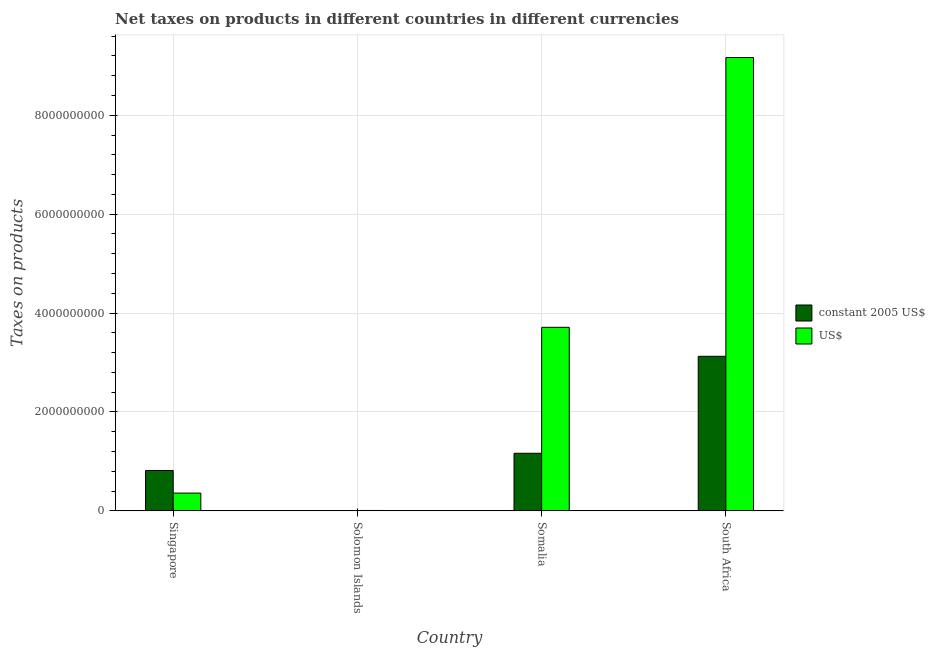How many different coloured bars are there?
Keep it short and to the point. 2. Are the number of bars on each tick of the X-axis equal?
Provide a succinct answer. Yes. How many bars are there on the 1st tick from the right?
Provide a short and direct response. 2. What is the label of the 1st group of bars from the left?
Your answer should be very brief. Singapore. What is the net taxes in constant 2005 us$ in Somalia?
Make the answer very short. 1.16e+09. Across all countries, what is the maximum net taxes in constant 2005 us$?
Provide a succinct answer. 3.12e+09. Across all countries, what is the minimum net taxes in constant 2005 us$?
Your answer should be compact. 6.60e+06. In which country was the net taxes in us$ maximum?
Provide a succinct answer. South Africa. In which country was the net taxes in us$ minimum?
Keep it short and to the point. Solomon Islands. What is the total net taxes in constant 2005 us$ in the graph?
Provide a succinct answer. 5.11e+09. What is the difference between the net taxes in constant 2005 us$ in Singapore and that in Somalia?
Offer a very short reply. -3.48e+08. What is the difference between the net taxes in us$ in Solomon Islands and the net taxes in constant 2005 us$ in South Africa?
Your answer should be compact. -3.12e+09. What is the average net taxes in us$ per country?
Provide a succinct answer. 3.31e+09. What is the difference between the net taxes in us$ and net taxes in constant 2005 us$ in Somalia?
Your answer should be very brief. 2.55e+09. What is the ratio of the net taxes in constant 2005 us$ in Solomon Islands to that in Somalia?
Your answer should be very brief. 0.01. What is the difference between the highest and the second highest net taxes in constant 2005 us$?
Keep it short and to the point. 1.96e+09. What is the difference between the highest and the lowest net taxes in constant 2005 us$?
Make the answer very short. 3.12e+09. What does the 1st bar from the left in Singapore represents?
Your answer should be compact. Constant 2005 us$. What does the 2nd bar from the right in South Africa represents?
Your answer should be very brief. Constant 2005 us$. How many bars are there?
Give a very brief answer. 8. What is the difference between two consecutive major ticks on the Y-axis?
Your response must be concise. 2.00e+09. Does the graph contain any zero values?
Provide a succinct answer. No. Does the graph contain grids?
Give a very brief answer. Yes. Where does the legend appear in the graph?
Your response must be concise. Center right. How many legend labels are there?
Provide a short and direct response. 2. How are the legend labels stacked?
Provide a short and direct response. Vertical. What is the title of the graph?
Ensure brevity in your answer.  Net taxes on products in different countries in different currencies. What is the label or title of the Y-axis?
Keep it short and to the point. Taxes on products. What is the Taxes on products of constant 2005 US$ in Singapore?
Offer a very short reply. 8.16e+08. What is the Taxes on products of US$ in Singapore?
Your answer should be very brief. 3.59e+08. What is the Taxes on products of constant 2005 US$ in Solomon Islands?
Your answer should be very brief. 6.60e+06. What is the Taxes on products of US$ in Solomon Islands?
Ensure brevity in your answer.  7.62e+06. What is the Taxes on products of constant 2005 US$ in Somalia?
Give a very brief answer. 1.16e+09. What is the Taxes on products in US$ in Somalia?
Ensure brevity in your answer.  3.71e+09. What is the Taxes on products in constant 2005 US$ in South Africa?
Your response must be concise. 3.12e+09. What is the Taxes on products in US$ in South Africa?
Offer a terse response. 9.17e+09. Across all countries, what is the maximum Taxes on products of constant 2005 US$?
Offer a very short reply. 3.12e+09. Across all countries, what is the maximum Taxes on products in US$?
Your answer should be very brief. 9.17e+09. Across all countries, what is the minimum Taxes on products in constant 2005 US$?
Keep it short and to the point. 6.60e+06. Across all countries, what is the minimum Taxes on products of US$?
Offer a very short reply. 7.62e+06. What is the total Taxes on products in constant 2005 US$ in the graph?
Your answer should be very brief. 5.11e+09. What is the total Taxes on products in US$ in the graph?
Provide a short and direct response. 1.32e+1. What is the difference between the Taxes on products of constant 2005 US$ in Singapore and that in Solomon Islands?
Keep it short and to the point. 8.09e+08. What is the difference between the Taxes on products in US$ in Singapore and that in Solomon Islands?
Provide a short and direct response. 3.51e+08. What is the difference between the Taxes on products of constant 2005 US$ in Singapore and that in Somalia?
Your response must be concise. -3.48e+08. What is the difference between the Taxes on products of US$ in Singapore and that in Somalia?
Your answer should be very brief. -3.35e+09. What is the difference between the Taxes on products in constant 2005 US$ in Singapore and that in South Africa?
Give a very brief answer. -2.31e+09. What is the difference between the Taxes on products in US$ in Singapore and that in South Africa?
Make the answer very short. -8.81e+09. What is the difference between the Taxes on products in constant 2005 US$ in Solomon Islands and that in Somalia?
Your answer should be compact. -1.16e+09. What is the difference between the Taxes on products in US$ in Solomon Islands and that in Somalia?
Offer a terse response. -3.70e+09. What is the difference between the Taxes on products in constant 2005 US$ in Solomon Islands and that in South Africa?
Offer a very short reply. -3.12e+09. What is the difference between the Taxes on products of US$ in Solomon Islands and that in South Africa?
Give a very brief answer. -9.16e+09. What is the difference between the Taxes on products in constant 2005 US$ in Somalia and that in South Africa?
Your response must be concise. -1.96e+09. What is the difference between the Taxes on products in US$ in Somalia and that in South Africa?
Give a very brief answer. -5.46e+09. What is the difference between the Taxes on products in constant 2005 US$ in Singapore and the Taxes on products in US$ in Solomon Islands?
Make the answer very short. 8.08e+08. What is the difference between the Taxes on products in constant 2005 US$ in Singapore and the Taxes on products in US$ in Somalia?
Your response must be concise. -2.90e+09. What is the difference between the Taxes on products of constant 2005 US$ in Singapore and the Taxes on products of US$ in South Africa?
Make the answer very short. -8.35e+09. What is the difference between the Taxes on products of constant 2005 US$ in Solomon Islands and the Taxes on products of US$ in Somalia?
Your answer should be compact. -3.70e+09. What is the difference between the Taxes on products of constant 2005 US$ in Solomon Islands and the Taxes on products of US$ in South Africa?
Provide a succinct answer. -9.16e+09. What is the difference between the Taxes on products in constant 2005 US$ in Somalia and the Taxes on products in US$ in South Africa?
Your answer should be compact. -8.00e+09. What is the average Taxes on products in constant 2005 US$ per country?
Your response must be concise. 1.28e+09. What is the average Taxes on products of US$ per country?
Offer a very short reply. 3.31e+09. What is the difference between the Taxes on products of constant 2005 US$ and Taxes on products of US$ in Singapore?
Provide a short and direct response. 4.57e+08. What is the difference between the Taxes on products in constant 2005 US$ and Taxes on products in US$ in Solomon Islands?
Keep it short and to the point. -1.02e+06. What is the difference between the Taxes on products in constant 2005 US$ and Taxes on products in US$ in Somalia?
Offer a terse response. -2.55e+09. What is the difference between the Taxes on products of constant 2005 US$ and Taxes on products of US$ in South Africa?
Offer a terse response. -6.04e+09. What is the ratio of the Taxes on products of constant 2005 US$ in Singapore to that in Solomon Islands?
Offer a very short reply. 123.64. What is the ratio of the Taxes on products of US$ in Singapore to that in Solomon Islands?
Provide a short and direct response. 47.08. What is the ratio of the Taxes on products of constant 2005 US$ in Singapore to that in Somalia?
Make the answer very short. 0.7. What is the ratio of the Taxes on products in US$ in Singapore to that in Somalia?
Your answer should be compact. 0.1. What is the ratio of the Taxes on products in constant 2005 US$ in Singapore to that in South Africa?
Ensure brevity in your answer.  0.26. What is the ratio of the Taxes on products of US$ in Singapore to that in South Africa?
Your response must be concise. 0.04. What is the ratio of the Taxes on products in constant 2005 US$ in Solomon Islands to that in Somalia?
Give a very brief answer. 0.01. What is the ratio of the Taxes on products of US$ in Solomon Islands to that in Somalia?
Keep it short and to the point. 0. What is the ratio of the Taxes on products of constant 2005 US$ in Solomon Islands to that in South Africa?
Your response must be concise. 0. What is the ratio of the Taxes on products of US$ in Solomon Islands to that in South Africa?
Give a very brief answer. 0. What is the ratio of the Taxes on products of constant 2005 US$ in Somalia to that in South Africa?
Provide a short and direct response. 0.37. What is the ratio of the Taxes on products in US$ in Somalia to that in South Africa?
Your answer should be very brief. 0.4. What is the difference between the highest and the second highest Taxes on products in constant 2005 US$?
Your response must be concise. 1.96e+09. What is the difference between the highest and the second highest Taxes on products in US$?
Offer a terse response. 5.46e+09. What is the difference between the highest and the lowest Taxes on products in constant 2005 US$?
Offer a very short reply. 3.12e+09. What is the difference between the highest and the lowest Taxes on products of US$?
Provide a short and direct response. 9.16e+09. 